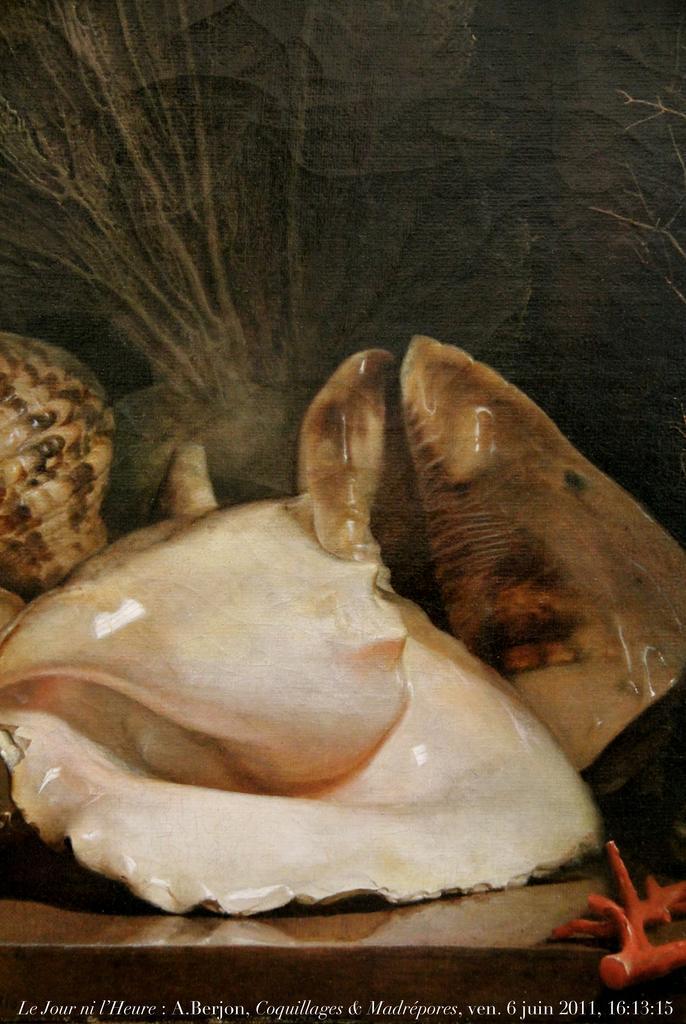Can you describe this image briefly? In the center of the image there is a platform. On the platform, we can see shells and one red color object. At the bottom of the image, we can see some text. In the background there is a wall. 